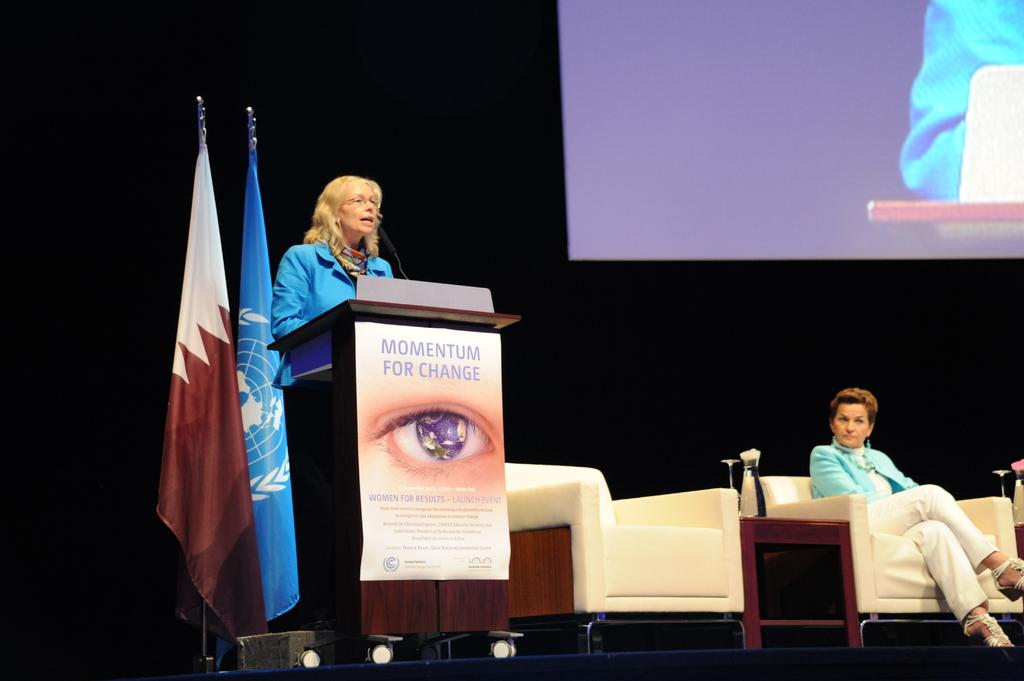What type of furniture is present in the image? There are couches in the image. What is the person on the couch doing? A person is sitting on a couch. What can be seen hanging in the image? There are flags in the image. What is the person standing in front of? The person is standing in front of a podium. What color is the background of the image? The background of the image is black. What large object is present in the image? There is a huge screen in the image. What type of body is visible in the image? There is no body present in the image; it features couches, flags, a podium, and a huge screen. What kind of feast is being prepared in the image? There is no feast being prepared in the image. What type of basket can be seen in the image? There is no basket present in the image. 